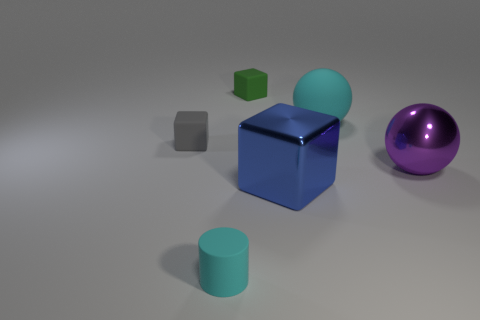Subtract all tiny gray matte blocks. How many blocks are left? 2 Add 3 blue blocks. How many objects exist? 9 Subtract all cylinders. How many objects are left? 5 Add 6 green cylinders. How many green cylinders exist? 6 Subtract 1 cyan cylinders. How many objects are left? 5 Subtract all large matte objects. Subtract all rubber objects. How many objects are left? 1 Add 2 rubber objects. How many rubber objects are left? 6 